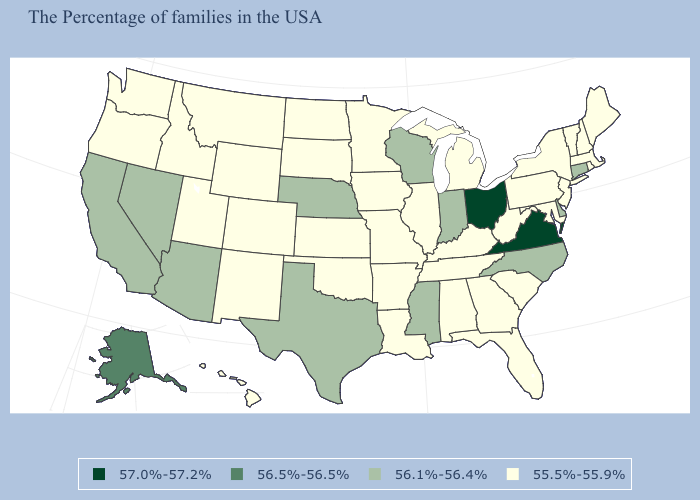What is the value of Arizona?
Quick response, please. 56.1%-56.4%. What is the highest value in the USA?
Be succinct. 57.0%-57.2%. Does Virginia have the highest value in the South?
Quick response, please. Yes. Name the states that have a value in the range 55.5%-55.9%?
Give a very brief answer. Maine, Massachusetts, Rhode Island, New Hampshire, Vermont, New York, New Jersey, Maryland, Pennsylvania, South Carolina, West Virginia, Florida, Georgia, Michigan, Kentucky, Alabama, Tennessee, Illinois, Louisiana, Missouri, Arkansas, Minnesota, Iowa, Kansas, Oklahoma, South Dakota, North Dakota, Wyoming, Colorado, New Mexico, Utah, Montana, Idaho, Washington, Oregon, Hawaii. What is the value of Delaware?
Be succinct. 56.1%-56.4%. What is the value of Alabama?
Write a very short answer. 55.5%-55.9%. Name the states that have a value in the range 57.0%-57.2%?
Answer briefly. Virginia, Ohio. What is the value of New Hampshire?
Keep it brief. 55.5%-55.9%. How many symbols are there in the legend?
Keep it brief. 4. What is the value of Texas?
Quick response, please. 56.1%-56.4%. Among the states that border Rhode Island , does Connecticut have the highest value?
Be succinct. Yes. Does the first symbol in the legend represent the smallest category?
Concise answer only. No. Name the states that have a value in the range 55.5%-55.9%?
Quick response, please. Maine, Massachusetts, Rhode Island, New Hampshire, Vermont, New York, New Jersey, Maryland, Pennsylvania, South Carolina, West Virginia, Florida, Georgia, Michigan, Kentucky, Alabama, Tennessee, Illinois, Louisiana, Missouri, Arkansas, Minnesota, Iowa, Kansas, Oklahoma, South Dakota, North Dakota, Wyoming, Colorado, New Mexico, Utah, Montana, Idaho, Washington, Oregon, Hawaii. What is the value of Arizona?
Answer briefly. 56.1%-56.4%. 